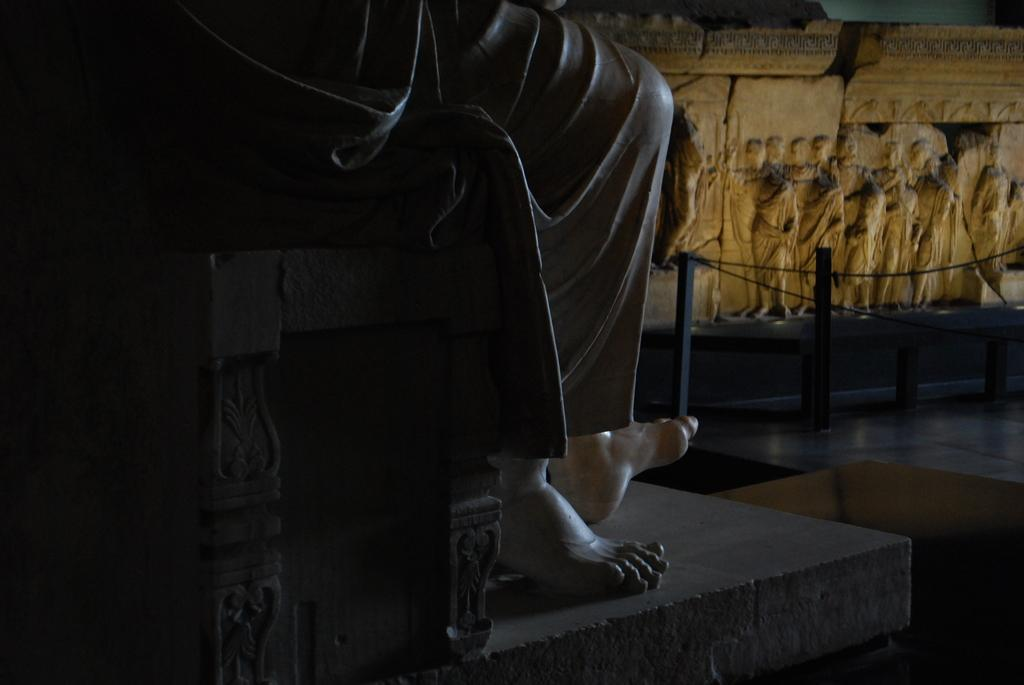What is the main subject in the image? There is a statue in the image. What part of the statue can be seen in the image? The statue has legs visible in the image. What type of architectural feature is present on the right side of the image? There is wall architecture on the right side of the image. What type of muscle can be seen in the statue's legs in the image? There is no muscle visible in the image; it is a statue, and therefore not a living being with muscles. 